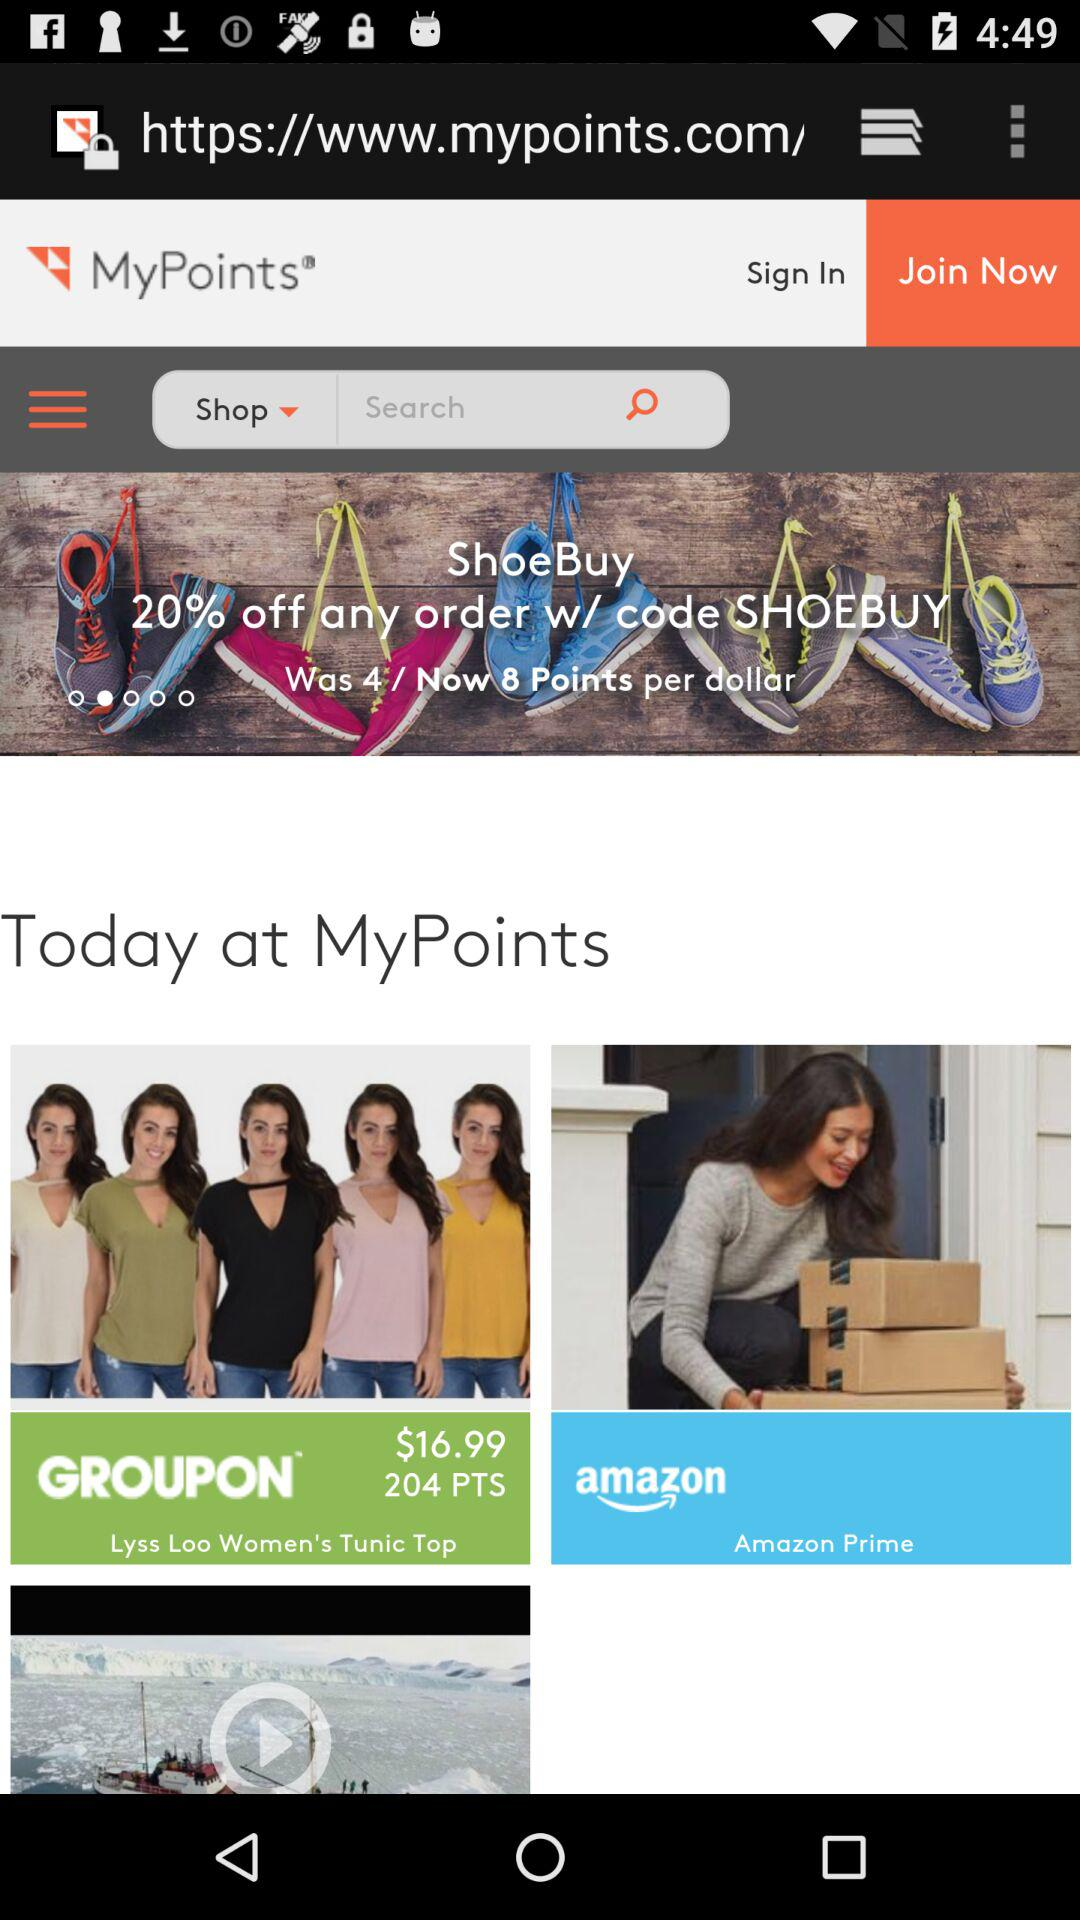How many points in total are there per dollar? There are 8 points per dollar. 